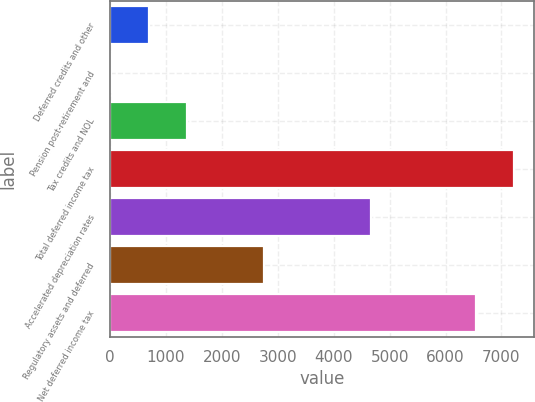Convert chart to OTSL. <chart><loc_0><loc_0><loc_500><loc_500><bar_chart><fcel>Deferred credits and other<fcel>Pension post-retirement and<fcel>Tax credits and NOL<fcel>Total deferred income tax<fcel>Accelerated depreciation rates<fcel>Regulatory assets and deferred<fcel>Net deferred income tax<nl><fcel>698.6<fcel>16<fcel>1381.2<fcel>7226.6<fcel>4664<fcel>2746.4<fcel>6544<nl></chart> 